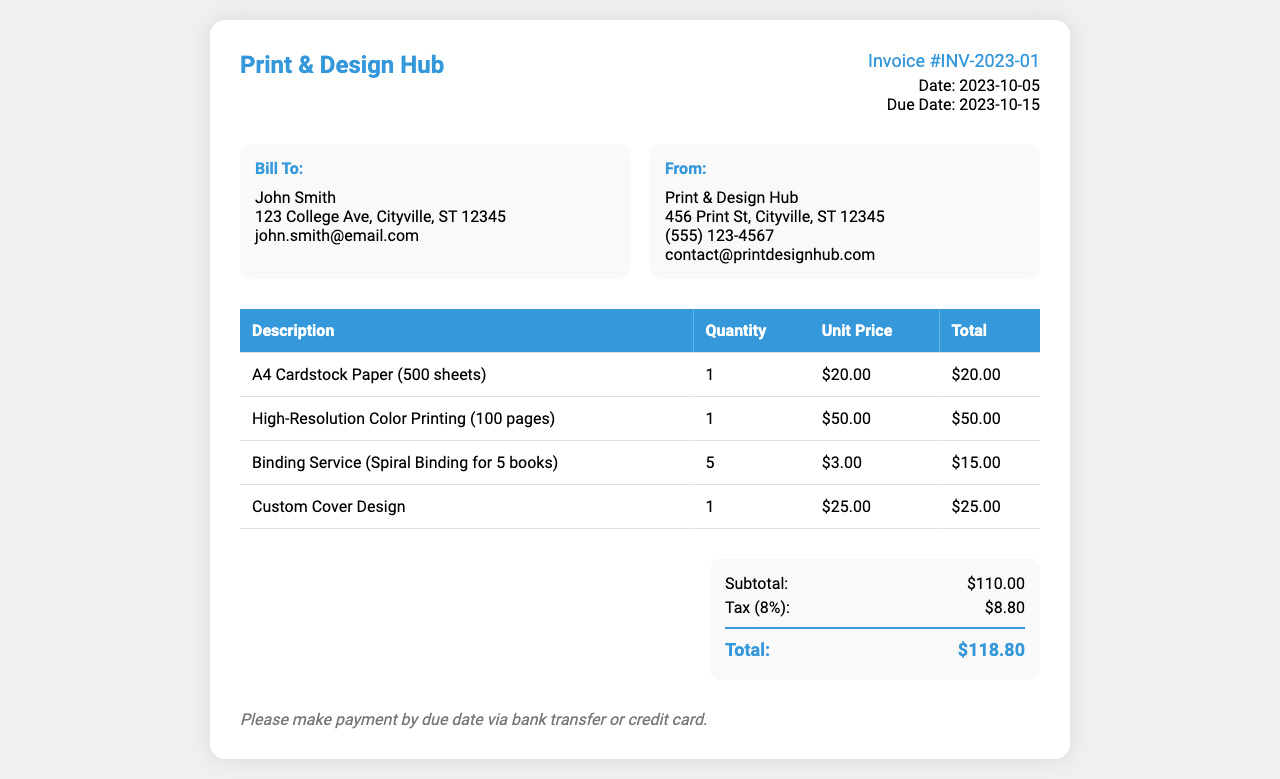What is the invoice number? The invoice number is a unique identifier for the transaction listed in the document, which is INV-2023-01.
Answer: INV-2023-01 What is the total amount due? The total amount due is the final total listed on the invoice after adding tax, which is $118.80.
Answer: $118.80 Who is the invoice billed to? The name of the person the invoice is addressed to is listed under "Bill To," which is John Smith.
Answer: John Smith What is the date of the invoice? The date of the invoice indicates when it was issued, which is 2023-10-05.
Answer: 2023-10-05 What is the unit price of A4 Cardstock Paper? The unit price for A4 Cardstock Paper is listed as $20.00 in the document.
Answer: $20.00 How many pages were printed in high resolution? The service for high-resolution color printing specifies the number of pages printed, which is 100 pages.
Answer: 100 pages What is the tax rate applied? The tax rate mentioned in the invoice is 8%, which is applied to the subtotal.
Answer: 8% How many binding services were provided? The quantity of binding services provided is noted in the document as 5.
Answer: 5 What is the due date for payment? The due date for payment is stated clearly in the document, which is 2023-10-15.
Answer: 2023-10-15 